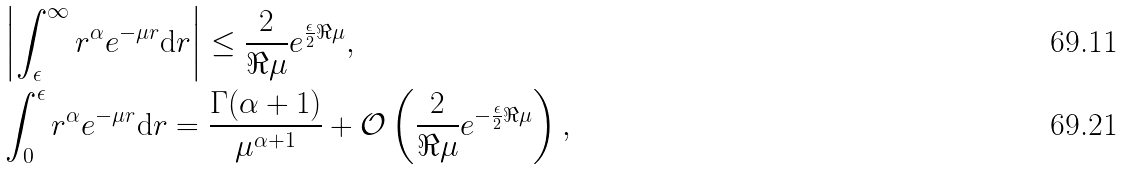Convert formula to latex. <formula><loc_0><loc_0><loc_500><loc_500>& \left | \int _ { \epsilon } ^ { \infty } r ^ { \alpha } e ^ { - \mu r } \mathrm d r \right | \leq \frac { 2 } { \Re \mu } e ^ { \frac { \epsilon } { 2 } \Re { \mu } } , \\ & \int _ { 0 } ^ { \epsilon } r ^ { \alpha } e ^ { - \mu r } \mathrm d r = \frac { \Gamma ( \alpha + 1 ) } { \mu ^ { \alpha + 1 } } + \mathcal { O } \left ( \frac { 2 } { \Re { \mu } } e ^ { - \frac { \epsilon } { 2 } \Re { \mu } } \right ) ,</formula> 